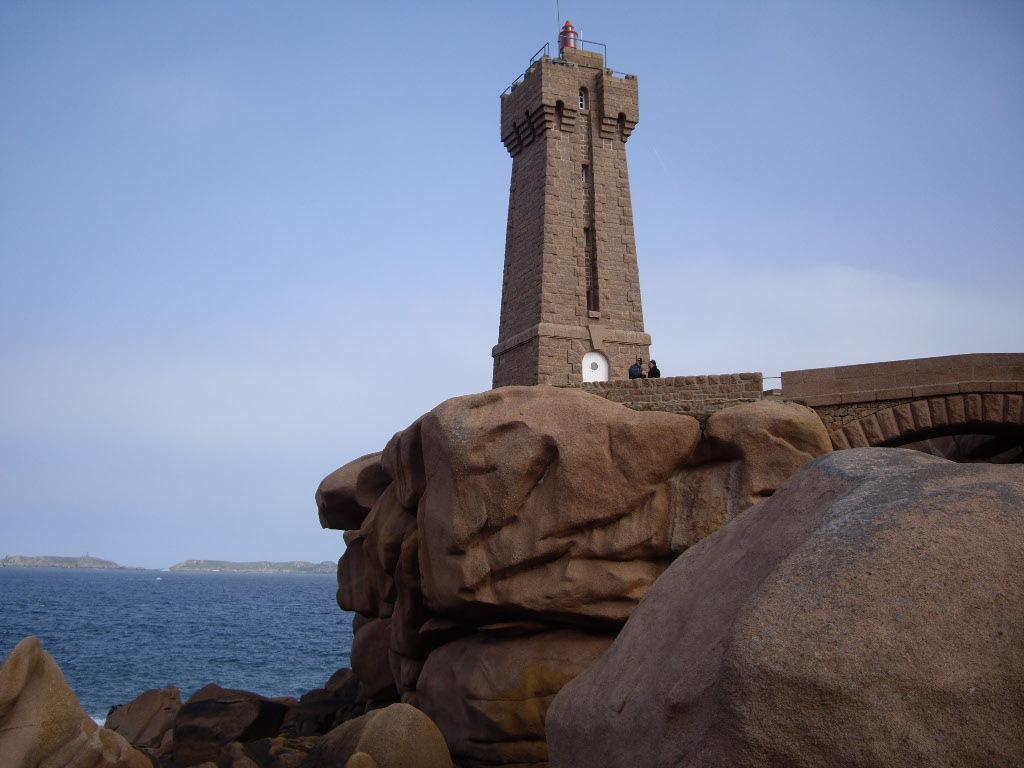Who or what can be seen in the image? There are people in the image. What structure is present in the image? There is a tower in the image. What type of barrier is visible in the image? There is a fence in the image. What natural elements can be seen in the image? There are rocks in the image. What can be seen in the distance in the image? There is water visible in the background of the image. What else is visible in the background of the image? The sky is visible in the background of the image. What type of quince is being used as a decoration in the image? There is no quince present in the image; it does not feature any fruit or decorations made from quince. How many sons are visible in the image? There is no mention of sons or any individuals with that specific relationship in the image. 